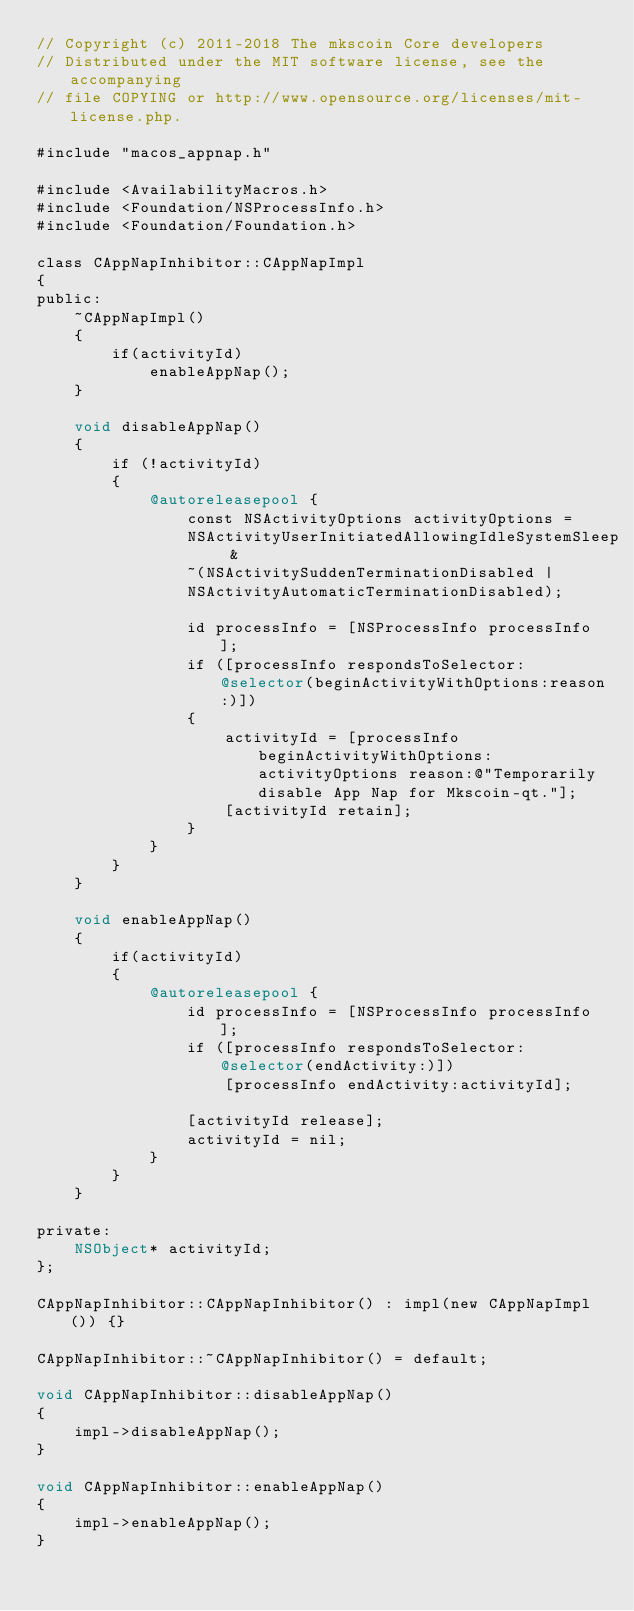<code> <loc_0><loc_0><loc_500><loc_500><_ObjectiveC_>// Copyright (c) 2011-2018 The mkscoin Core developers
// Distributed under the MIT software license, see the accompanying
// file COPYING or http://www.opensource.org/licenses/mit-license.php.

#include "macos_appnap.h"

#include <AvailabilityMacros.h>
#include <Foundation/NSProcessInfo.h>
#include <Foundation/Foundation.h>

class CAppNapInhibitor::CAppNapImpl
{
public:
    ~CAppNapImpl()
    {
        if(activityId)
            enableAppNap();
    }

    void disableAppNap()
    {
        if (!activityId)
        {
            @autoreleasepool {
                const NSActivityOptions activityOptions =
                NSActivityUserInitiatedAllowingIdleSystemSleep &
                ~(NSActivitySuddenTerminationDisabled |
                NSActivityAutomaticTerminationDisabled);

                id processInfo = [NSProcessInfo processInfo];
                if ([processInfo respondsToSelector:@selector(beginActivityWithOptions:reason:)])
                {
                    activityId = [processInfo beginActivityWithOptions: activityOptions reason:@"Temporarily disable App Nap for Mkscoin-qt."];
                    [activityId retain];
                }
            }
        }
    }

    void enableAppNap()
    {
        if(activityId)
        {
            @autoreleasepool {
                id processInfo = [NSProcessInfo processInfo];
                if ([processInfo respondsToSelector:@selector(endActivity:)])
                    [processInfo endActivity:activityId];

                [activityId release];
                activityId = nil;
            }
        }
    }

private:
    NSObject* activityId;
};

CAppNapInhibitor::CAppNapInhibitor() : impl(new CAppNapImpl()) {}

CAppNapInhibitor::~CAppNapInhibitor() = default;

void CAppNapInhibitor::disableAppNap()
{
    impl->disableAppNap();
}

void CAppNapInhibitor::enableAppNap()
{
    impl->enableAppNap();
}
</code> 